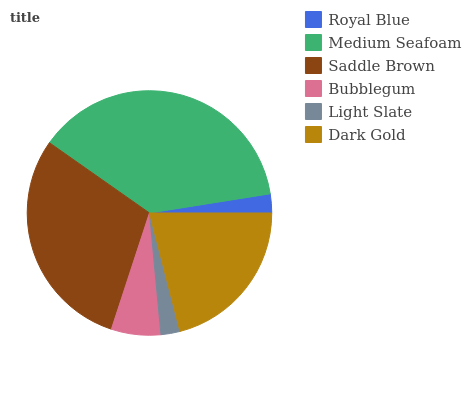Is Royal Blue the minimum?
Answer yes or no. Yes. Is Medium Seafoam the maximum?
Answer yes or no. Yes. Is Saddle Brown the minimum?
Answer yes or no. No. Is Saddle Brown the maximum?
Answer yes or no. No. Is Medium Seafoam greater than Saddle Brown?
Answer yes or no. Yes. Is Saddle Brown less than Medium Seafoam?
Answer yes or no. Yes. Is Saddle Brown greater than Medium Seafoam?
Answer yes or no. No. Is Medium Seafoam less than Saddle Brown?
Answer yes or no. No. Is Dark Gold the high median?
Answer yes or no. Yes. Is Bubblegum the low median?
Answer yes or no. Yes. Is Medium Seafoam the high median?
Answer yes or no. No. Is Royal Blue the low median?
Answer yes or no. No. 